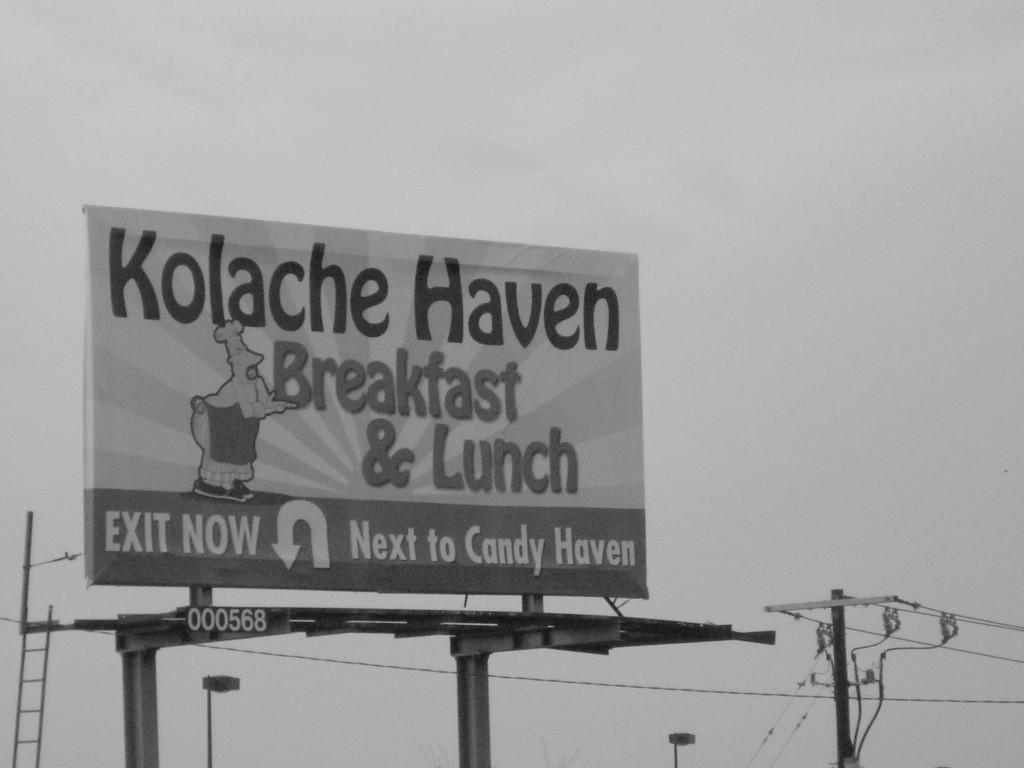What is the color scheme of the image? The image is black and white. What can be seen hanging in the picture? There is a banner with text and an image in the picture. What other objects are present in the image? There are poles with lights and wires in the picture. Is there any equipment for climbing visible in the image? Yes, there is a ladder visible in the picture. Can you tell me how many bees are sitting on the banner in the image? There are no bees present in the image; it only features a banner with text and an image. What type of seat can be seen on the ladder in the image? There is no seat on the ladder in the image; it is a simple ladder without any additional features. 